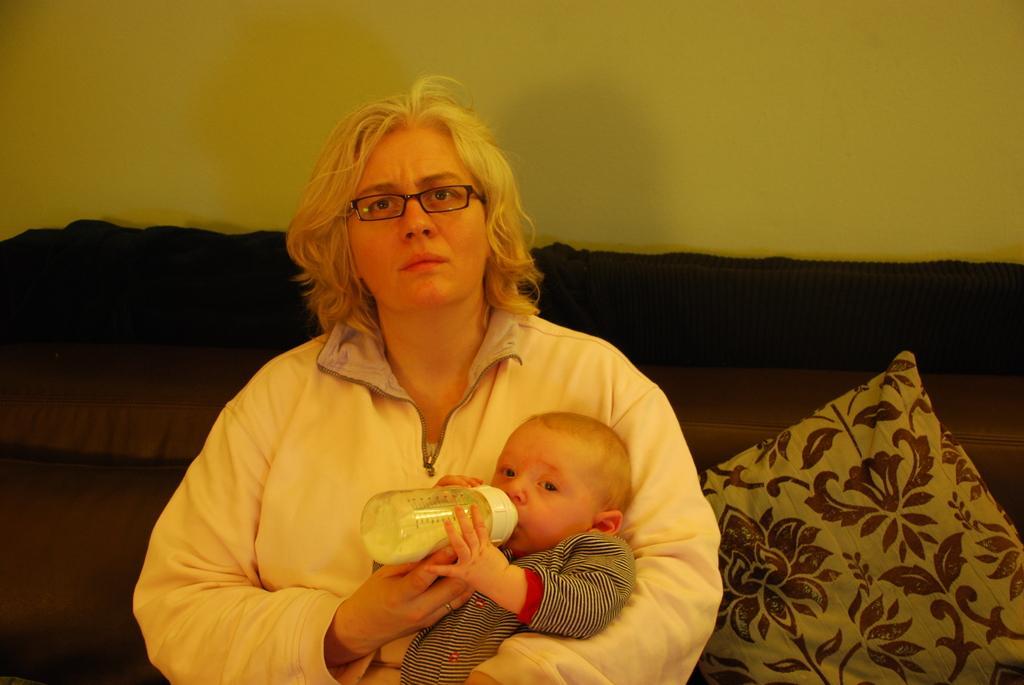Can you describe this image briefly? In this picture we can see woman carrying baby with her hand and baby is drinking milk with bottle and this two are on sofa with pillow on it and in background we can see wall. 